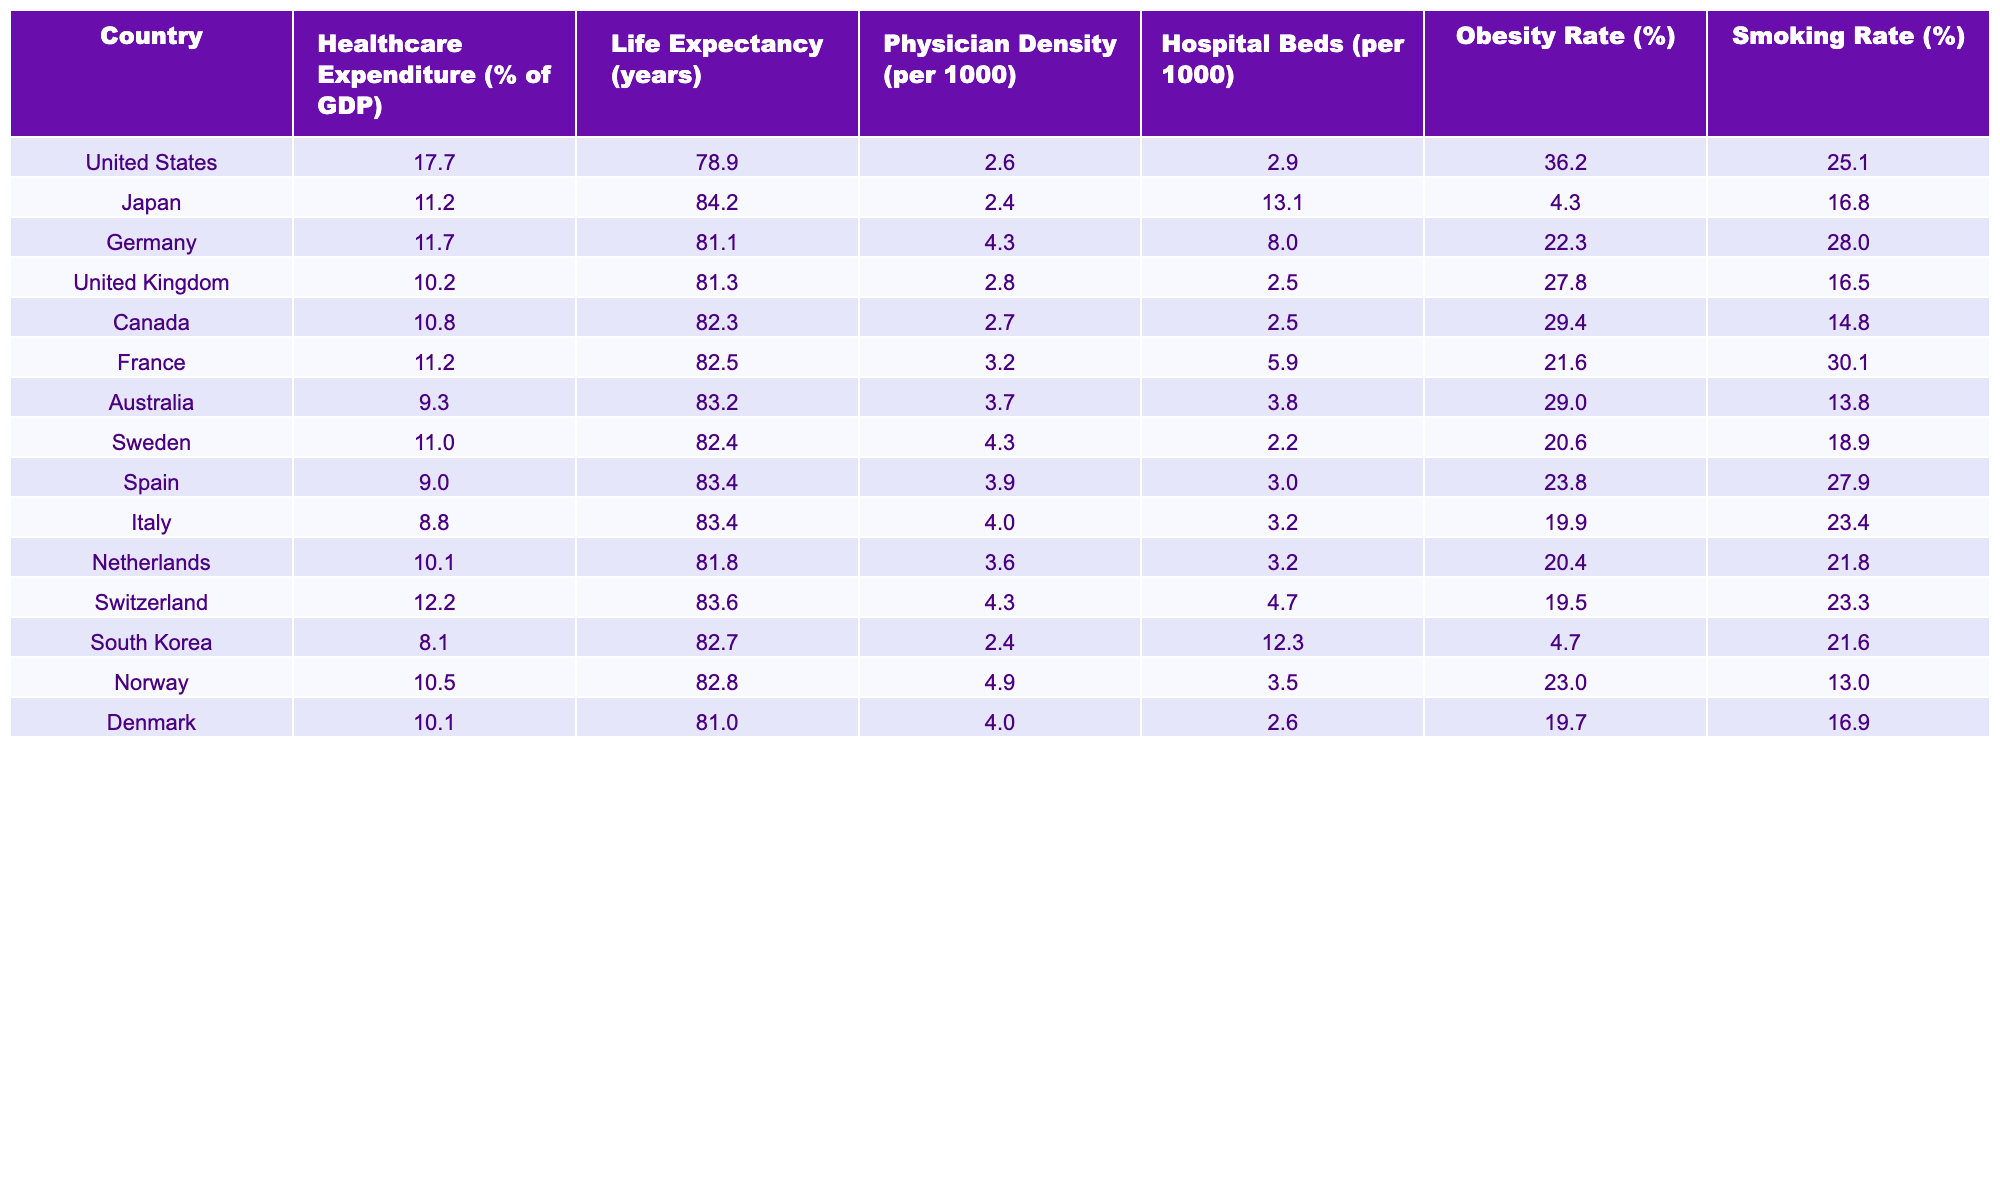What is the healthcare expenditure as a percentage of GDP for Japan? Referring to the table, Japan has a healthcare expenditure of 11.2% of GDP.
Answer: 11.2% Which country has the highest life expectancy? By comparing the life expectancy values in the table, Japan has the highest life expectancy at 84.2 years.
Answer: Japan What is the average obesity rate of the countries listed? To calculate the average, sum the obesity rates of all countries: (36.2 + 4.3 + 22.3 + 27.8 + 29.4 + 21.6 + 29.0 + 20.6 + 23.8 + 19.9 + 20.4 + 19.5 + 4.7 + 23.0 + 19.7) =  357.2. There are 15 countries, so the average is 357.2 / 15 = approximately 23.8%.
Answer: 23.8% Is it true that the Netherlands has a higher physician density compared to the United States? The physician density for the Netherlands is 3.6 per 1000 and for the United States, it is 2.6 per 1000. Since 3.6 is greater than 2.6, it is true that the Netherlands has a higher physician density.
Answer: Yes Which country has the lowest healthcare expenditure and what is the amount? Looking at the table, Spain shows the lowest healthcare expenditure at 9.0% of GDP.
Answer: Spain, 9.0% What is the difference in life expectancy between the United States and Australia? The life expectancy in the United States is 78.9 years and in Australia, it is 83.2 years. The difference is 83.2 - 78.9 = 4.3 years.
Answer: 4.3 years Confirm or refute: Sweden has a higher number of hospital beds per 1000 compared to Italy. The table shows Sweden has 2.2 hospital beds per 1000 while Italy has 3.2. Since 2.2 is less than 3.2, the statement is false.
Answer: False What is the relationship between obesity rates and life expectancy in the countries listed? To explore the relationship, observe that countries with higher obesity rates, such as the United States (36.2%) and Germany (22.3%), have lower life expectancies (78.9 and 81.1 years, respectively), while countries like Japan (4.3%) have higher life expectancy (84.2 years). This suggests an inverse relationship between obesity rates and life expectancy.
Answer: Inverse relationship What is the average smoking rate across all countries in the table? Sum the smoking rates: (25.1 + 16.8 + 28.0 + 16.5 + 14.8 + 30.1 + 13.8 + 18.9 + 27.9 + 23.4 + 21.8 + 23.3 + 21.6 + 13.0 + 16.9) =  332.2. Dividing by the 15 countries gives an average of 332.2 / 15 = approximately 22.1%.
Answer: 22.1% Which country has both the lowest healthcare expenditure and the lowest life expectancy among the OECD countries listed? Reviewing the table, Spain holds the lowest healthcare expenditure at 9.0% of GDP and has a life expectancy of 83.4 years; however, the United States, with a higher expenditure of 17.7%, presents a life expectancy of 78.9 years, which is lower. Hence, the United States has the lowest life expectancy.
Answer: United States 